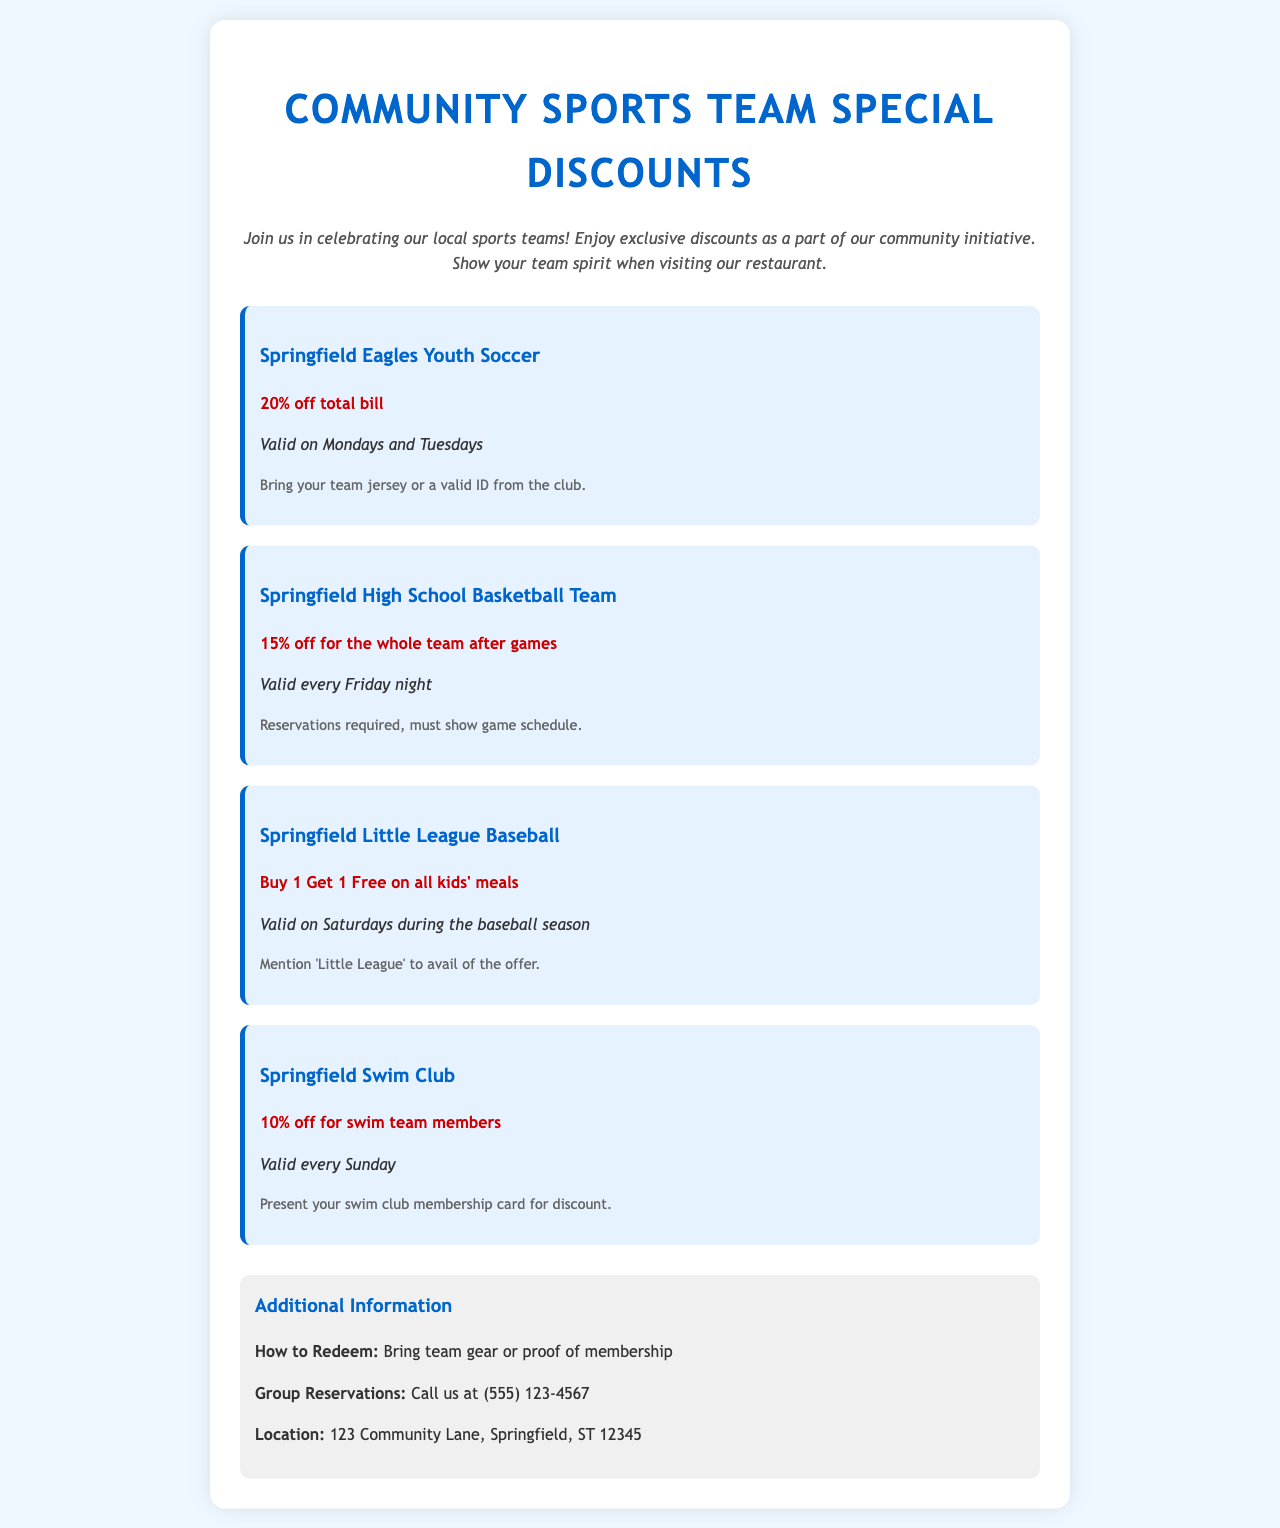What discount do the Springfield Eagles Youth Soccer members receive? The discount for the Springfield Eagles Youth Soccer is 20% off total bill.
Answer: 20% off total bill On what days is the Springfield High School Basketball Team's discount valid? The Springfield High School Basketball Team's discount is valid every Friday night.
Answer: Every Friday night What must be shown to redeem the Springfield Little League Baseball offer? To redeem the offer for Springfield Little League Baseball, you must mention 'Little League'.
Answer: 'Little League' What is the discount for Springfield Swim Club members? The discount for Springfield Swim Club members is 10% off.
Answer: 10% off How can group reservations be made? Group reservations can be made by calling the restaurant.
Answer: Call us at (555) 123-4567 What is required for the Springfield High School Basketball Team discount? Reservations are required and must show game schedule.
Answer: Reservations required, must show game schedule On which day can members of the Springfield Swim Club receive their discount? Members of the Springfield Swim Club can receive their discount every Sunday.
Answer: Every Sunday What is the location of the restaurant offering the discounts? The location of the restaurant is mentioned as 123 Community Lane, Springfield, ST 12345.
Answer: 123 Community Lane, Springfield, ST 12345 